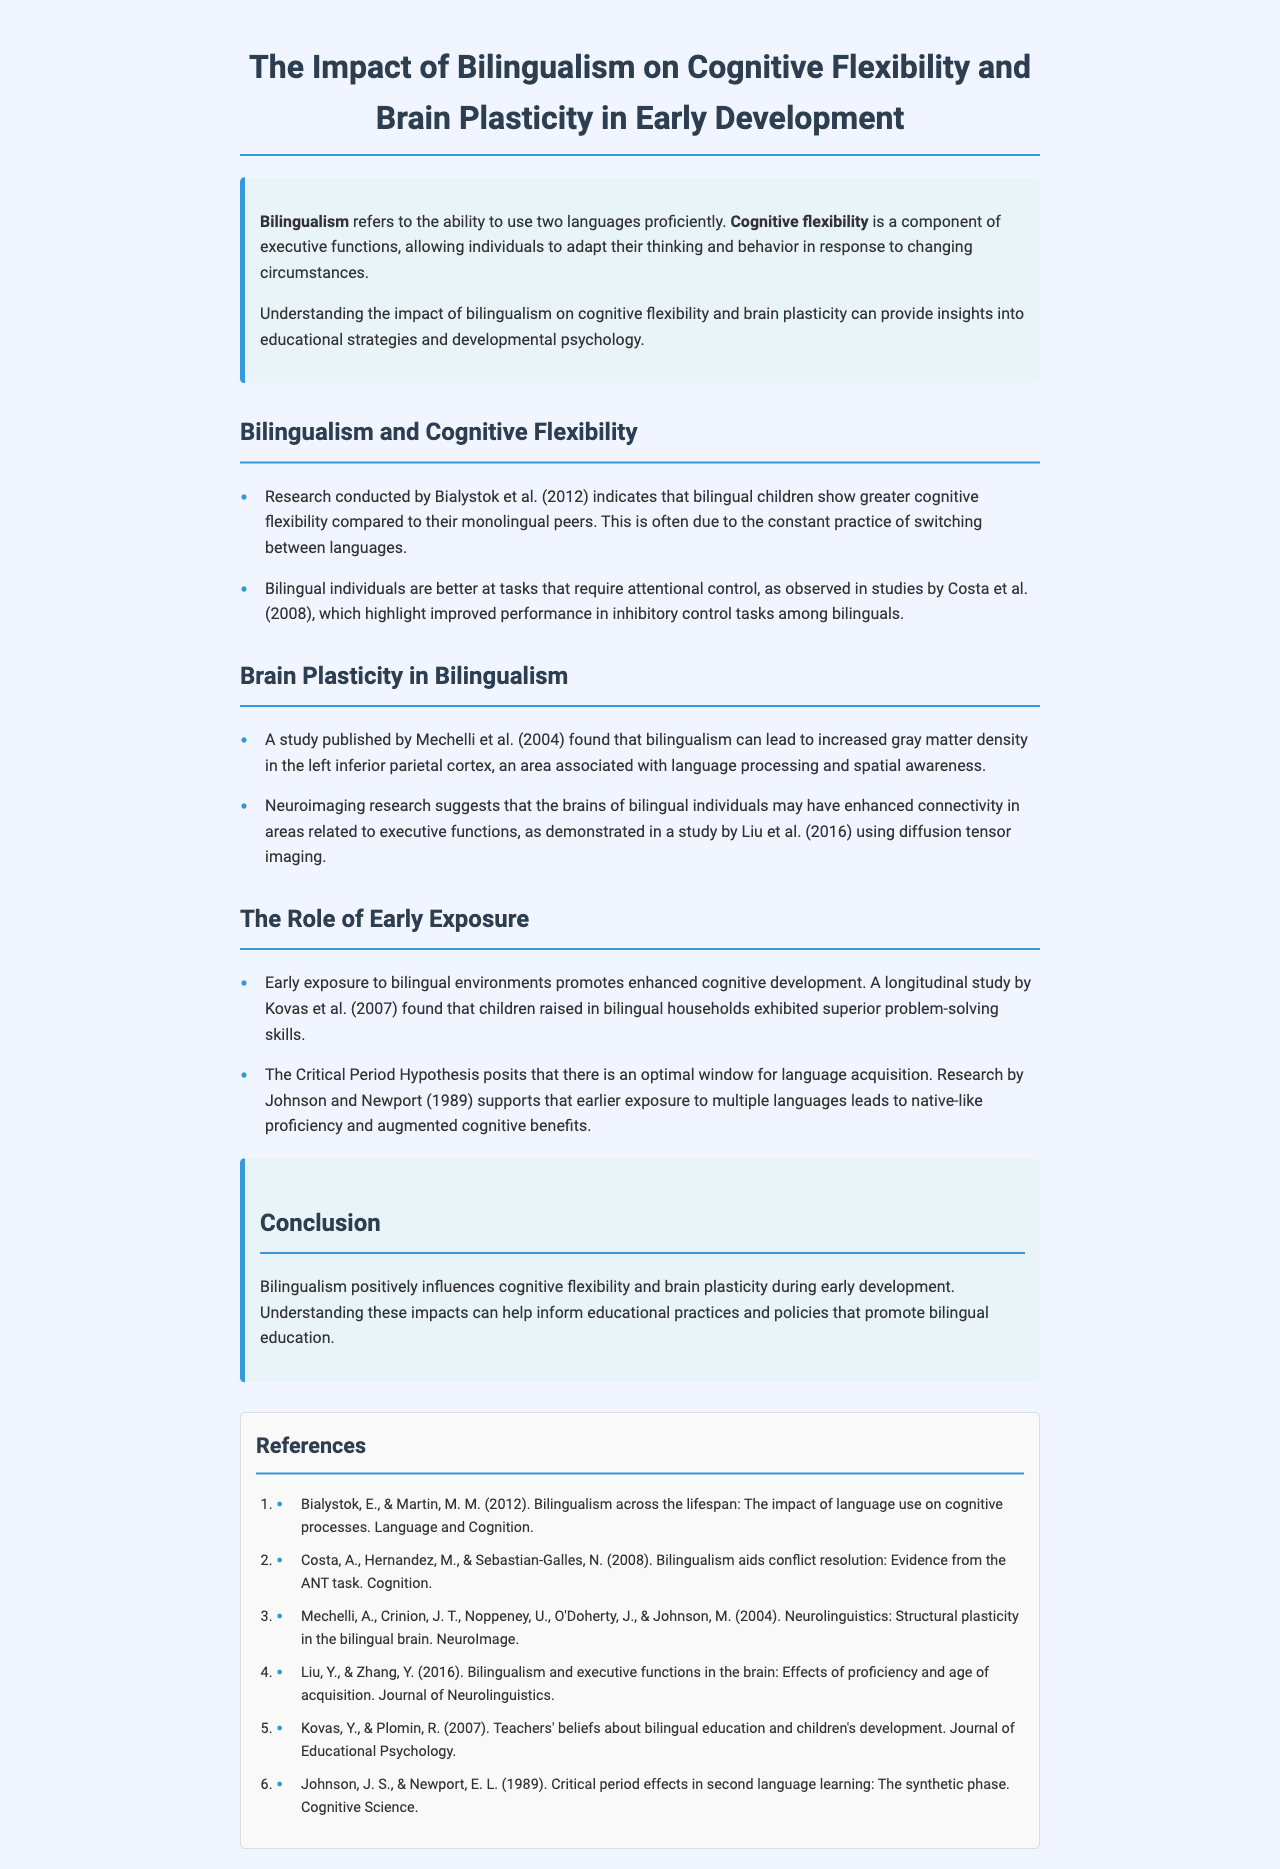What is the main focus of the report? The main focus of the report is to explore the impact of bilingualism on cognitive flexibility and brain plasticity in early development.
Answer: bilingualism on cognitive flexibility and brain plasticity Who conducted research indicating greater cognitive flexibility in bilingual children? Bialystok et al. are mentioned for their research indicating that bilingual children show greater cognitive flexibility.
Answer: Bialystok et al What area of the brain showed increased gray matter density due to bilingualism? The left inferior parietal cortex is specified as showing increased gray matter density due to bilingualism.
Answer: left inferior parietal cortex What hypothesis supports the optimal window for language acquisition? The Critical Period Hypothesis is stated as supporting the optimal window for language acquisition.
Answer: Critical Period Hypothesis What year was the study published by Kovas and Plomin? The study by Kovas and Plomin was published in 2007.
Answer: 2007 What benefit do bilingual individuals have according to Costa et al. (2008)? According to Costa et al. (2008), bilingual individuals are better at tasks requiring attentional control.
Answer: attentional control What aspect of development does early exposure to bilingual environments enhance? Early exposure to bilingual environments enhances cognitive development.
Answer: cognitive development Which publication discusses the structural plasticity in the bilingual brain? The study by Mechelli et al. (2004) discusses structural plasticity in the bilingual brain.
Answer: Mechelli et al. (2004) 